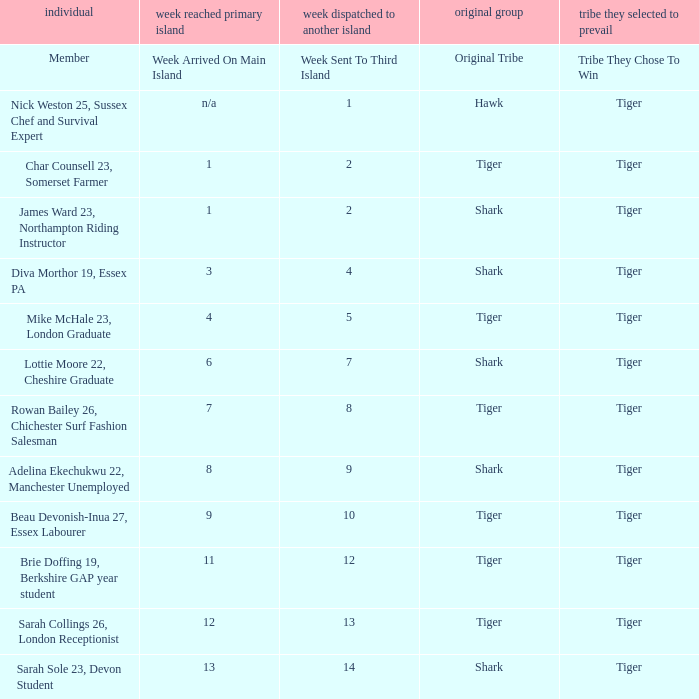How many members arrived on the main island in week 4? 1.0. Parse the table in full. {'header': ['individual', 'week reached primary island', 'week dispatched to another island', 'original group', 'tribe they selected to prevail'], 'rows': [['Member', 'Week Arrived On Main Island', 'Week Sent To Third Island', 'Original Tribe', 'Tribe They Chose To Win'], ['Nick Weston 25, Sussex Chef and Survival Expert', 'n/a', '1', 'Hawk', 'Tiger'], ['Char Counsell 23, Somerset Farmer', '1', '2', 'Tiger', 'Tiger'], ['James Ward 23, Northampton Riding Instructor', '1', '2', 'Shark', 'Tiger'], ['Diva Morthor 19, Essex PA', '3', '4', 'Shark', 'Tiger'], ['Mike McHale 23, London Graduate', '4', '5', 'Tiger', 'Tiger'], ['Lottie Moore 22, Cheshire Graduate', '6', '7', 'Shark', 'Tiger'], ['Rowan Bailey 26, Chichester Surf Fashion Salesman', '7', '8', 'Tiger', 'Tiger'], ['Adelina Ekechukwu 22, Manchester Unemployed', '8', '9', 'Shark', 'Tiger'], ['Beau Devonish-Inua 27, Essex Labourer', '9', '10', 'Tiger', 'Tiger'], ['Brie Doffing 19, Berkshire GAP year student', '11', '12', 'Tiger', 'Tiger'], ['Sarah Collings 26, London Receptionist', '12', '13', 'Tiger', 'Tiger'], ['Sarah Sole 23, Devon Student', '13', '14', 'Shark', 'Tiger']]} 